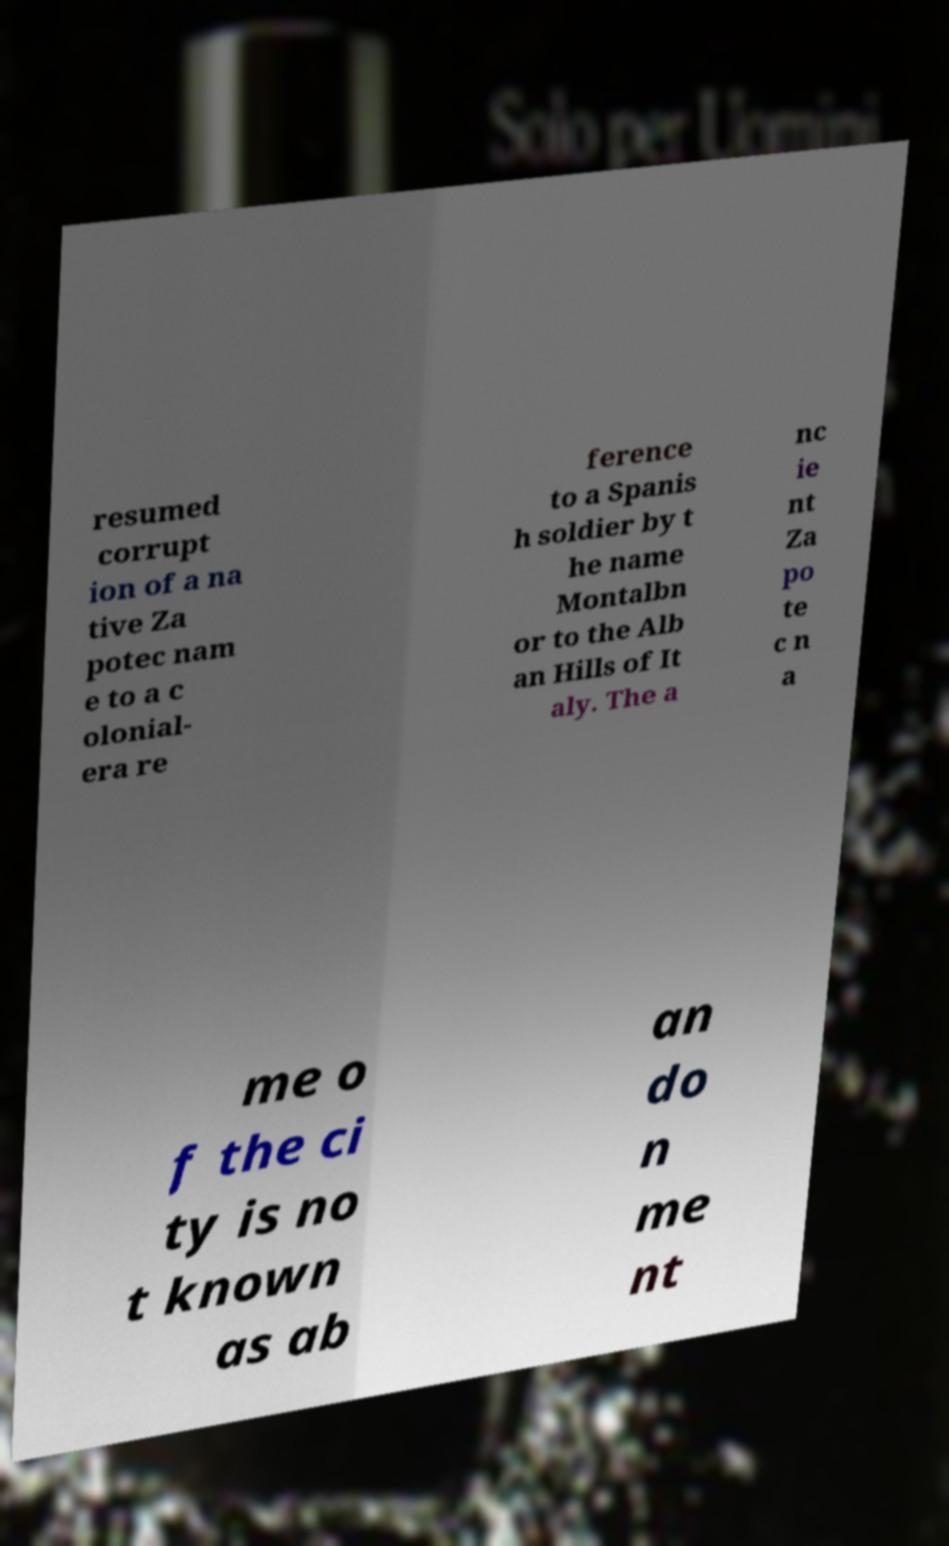For documentation purposes, I need the text within this image transcribed. Could you provide that? resumed corrupt ion of a na tive Za potec nam e to a c olonial- era re ference to a Spanis h soldier by t he name Montalbn or to the Alb an Hills of It aly. The a nc ie nt Za po te c n a me o f the ci ty is no t known as ab an do n me nt 